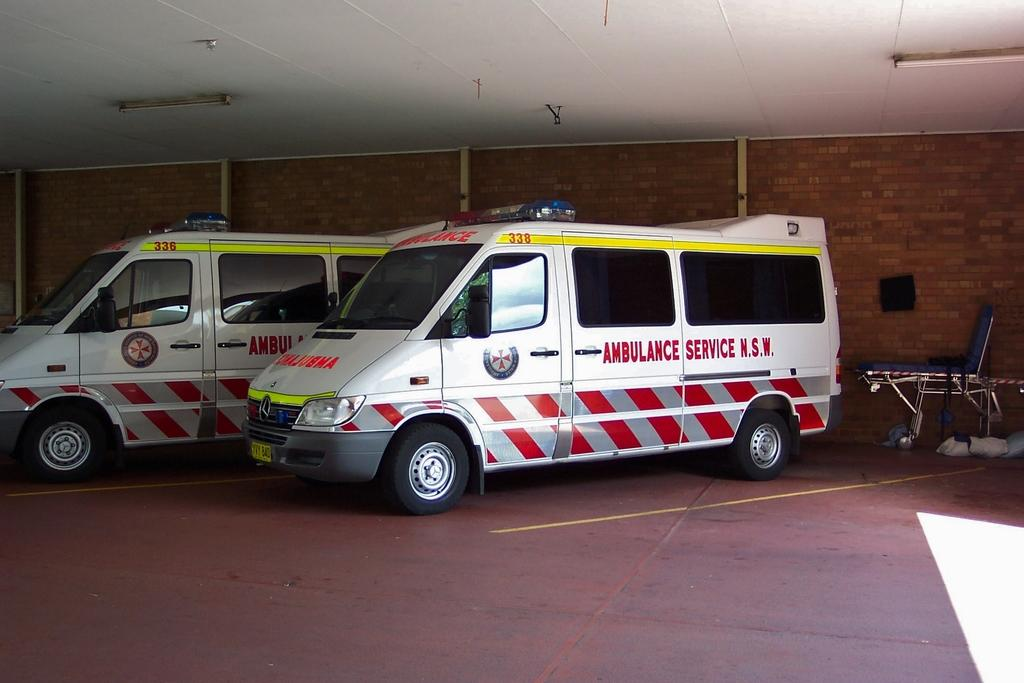Provide a one-sentence caption for the provided image. A white ambulance with red and silver stripes on it in N.S.W. 